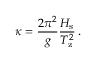<formula> <loc_0><loc_0><loc_500><loc_500>\kappa = \frac { 2 \pi ^ { 2 } } { g } \frac { H _ { s } } { T _ { z } ^ { 2 } } \, .</formula> 